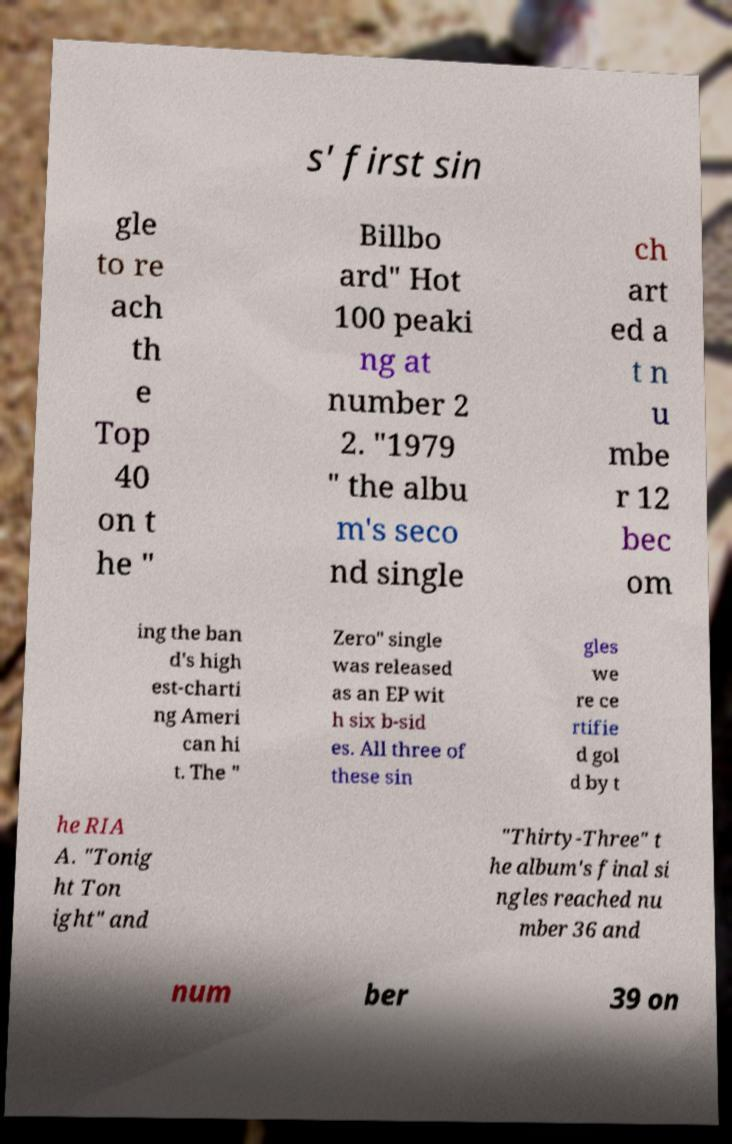What messages or text are displayed in this image? I need them in a readable, typed format. s' first sin gle to re ach th e Top 40 on t he " Billbo ard" Hot 100 peaki ng at number 2 2. "1979 " the albu m's seco nd single ch art ed a t n u mbe r 12 bec om ing the ban d's high est-charti ng Ameri can hi t. The " Zero" single was released as an EP wit h six b-sid es. All three of these sin gles we re ce rtifie d gol d by t he RIA A. "Tonig ht Ton ight" and "Thirty-Three" t he album's final si ngles reached nu mber 36 and num ber 39 on 